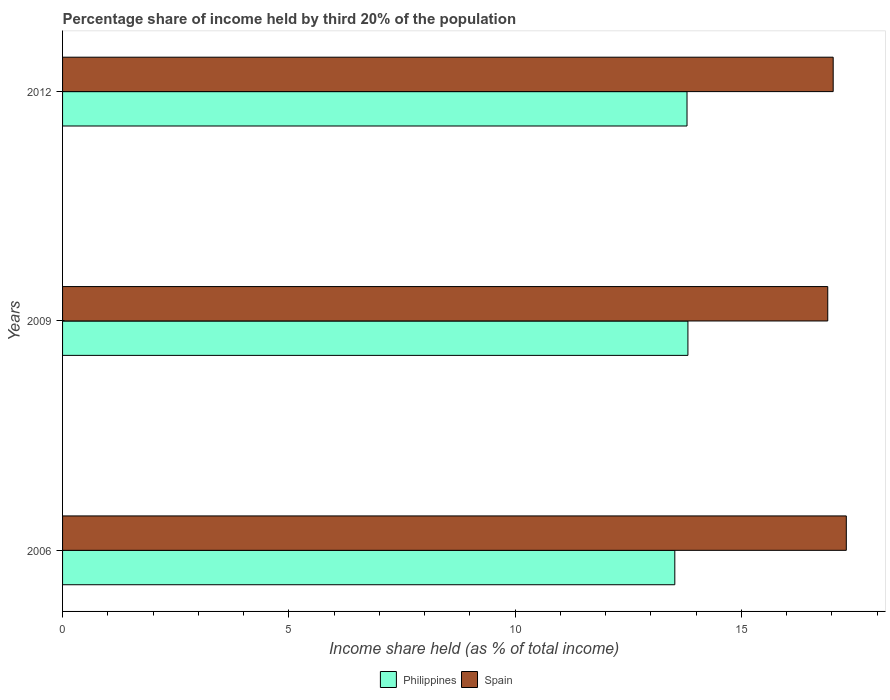How many groups of bars are there?
Give a very brief answer. 3. What is the label of the 3rd group of bars from the top?
Give a very brief answer. 2006. In how many cases, is the number of bars for a given year not equal to the number of legend labels?
Make the answer very short. 0. What is the share of income held by third 20% of the population in Spain in 2006?
Offer a very short reply. 17.32. Across all years, what is the maximum share of income held by third 20% of the population in Spain?
Ensure brevity in your answer.  17.32. Across all years, what is the minimum share of income held by third 20% of the population in Philippines?
Give a very brief answer. 13.53. What is the total share of income held by third 20% of the population in Spain in the graph?
Ensure brevity in your answer.  51.26. What is the difference between the share of income held by third 20% of the population in Spain in 2006 and that in 2009?
Provide a succinct answer. 0.41. What is the difference between the share of income held by third 20% of the population in Spain in 2006 and the share of income held by third 20% of the population in Philippines in 2012?
Ensure brevity in your answer.  3.52. What is the average share of income held by third 20% of the population in Spain per year?
Ensure brevity in your answer.  17.09. In the year 2012, what is the difference between the share of income held by third 20% of the population in Philippines and share of income held by third 20% of the population in Spain?
Keep it short and to the point. -3.23. In how many years, is the share of income held by third 20% of the population in Philippines greater than 7 %?
Your response must be concise. 3. What is the ratio of the share of income held by third 20% of the population in Spain in 2006 to that in 2009?
Your response must be concise. 1.02. Is the share of income held by third 20% of the population in Spain in 2009 less than that in 2012?
Provide a succinct answer. Yes. Is the difference between the share of income held by third 20% of the population in Philippines in 2006 and 2009 greater than the difference between the share of income held by third 20% of the population in Spain in 2006 and 2009?
Provide a short and direct response. No. What is the difference between the highest and the second highest share of income held by third 20% of the population in Philippines?
Provide a short and direct response. 0.02. What is the difference between the highest and the lowest share of income held by third 20% of the population in Philippines?
Offer a very short reply. 0.29. In how many years, is the share of income held by third 20% of the population in Philippines greater than the average share of income held by third 20% of the population in Philippines taken over all years?
Provide a short and direct response. 2. Is the sum of the share of income held by third 20% of the population in Spain in 2009 and 2012 greater than the maximum share of income held by third 20% of the population in Philippines across all years?
Your answer should be very brief. Yes. What does the 2nd bar from the bottom in 2006 represents?
Give a very brief answer. Spain. How many bars are there?
Provide a short and direct response. 6. What is the difference between two consecutive major ticks on the X-axis?
Offer a terse response. 5. Does the graph contain any zero values?
Offer a terse response. No. Does the graph contain grids?
Offer a terse response. No. Where does the legend appear in the graph?
Give a very brief answer. Bottom center. What is the title of the graph?
Make the answer very short. Percentage share of income held by third 20% of the population. What is the label or title of the X-axis?
Your answer should be very brief. Income share held (as % of total income). What is the label or title of the Y-axis?
Make the answer very short. Years. What is the Income share held (as % of total income) of Philippines in 2006?
Give a very brief answer. 13.53. What is the Income share held (as % of total income) of Spain in 2006?
Ensure brevity in your answer.  17.32. What is the Income share held (as % of total income) of Philippines in 2009?
Offer a very short reply. 13.82. What is the Income share held (as % of total income) of Spain in 2009?
Your answer should be compact. 16.91. What is the Income share held (as % of total income) in Spain in 2012?
Provide a short and direct response. 17.03. Across all years, what is the maximum Income share held (as % of total income) of Philippines?
Offer a very short reply. 13.82. Across all years, what is the maximum Income share held (as % of total income) of Spain?
Provide a short and direct response. 17.32. Across all years, what is the minimum Income share held (as % of total income) of Philippines?
Provide a short and direct response. 13.53. Across all years, what is the minimum Income share held (as % of total income) of Spain?
Make the answer very short. 16.91. What is the total Income share held (as % of total income) of Philippines in the graph?
Ensure brevity in your answer.  41.15. What is the total Income share held (as % of total income) of Spain in the graph?
Provide a succinct answer. 51.26. What is the difference between the Income share held (as % of total income) of Philippines in 2006 and that in 2009?
Provide a succinct answer. -0.29. What is the difference between the Income share held (as % of total income) in Spain in 2006 and that in 2009?
Ensure brevity in your answer.  0.41. What is the difference between the Income share held (as % of total income) of Philippines in 2006 and that in 2012?
Keep it short and to the point. -0.27. What is the difference between the Income share held (as % of total income) in Spain in 2006 and that in 2012?
Make the answer very short. 0.29. What is the difference between the Income share held (as % of total income) of Philippines in 2009 and that in 2012?
Ensure brevity in your answer.  0.02. What is the difference between the Income share held (as % of total income) in Spain in 2009 and that in 2012?
Your response must be concise. -0.12. What is the difference between the Income share held (as % of total income) of Philippines in 2006 and the Income share held (as % of total income) of Spain in 2009?
Offer a terse response. -3.38. What is the difference between the Income share held (as % of total income) of Philippines in 2009 and the Income share held (as % of total income) of Spain in 2012?
Your answer should be compact. -3.21. What is the average Income share held (as % of total income) in Philippines per year?
Offer a terse response. 13.72. What is the average Income share held (as % of total income) in Spain per year?
Offer a very short reply. 17.09. In the year 2006, what is the difference between the Income share held (as % of total income) of Philippines and Income share held (as % of total income) of Spain?
Keep it short and to the point. -3.79. In the year 2009, what is the difference between the Income share held (as % of total income) in Philippines and Income share held (as % of total income) in Spain?
Your answer should be compact. -3.09. In the year 2012, what is the difference between the Income share held (as % of total income) in Philippines and Income share held (as % of total income) in Spain?
Provide a succinct answer. -3.23. What is the ratio of the Income share held (as % of total income) of Spain in 2006 to that in 2009?
Give a very brief answer. 1.02. What is the ratio of the Income share held (as % of total income) in Philippines in 2006 to that in 2012?
Ensure brevity in your answer.  0.98. What is the ratio of the Income share held (as % of total income) in Spain in 2009 to that in 2012?
Your answer should be compact. 0.99. What is the difference between the highest and the second highest Income share held (as % of total income) of Philippines?
Make the answer very short. 0.02. What is the difference between the highest and the second highest Income share held (as % of total income) in Spain?
Your response must be concise. 0.29. What is the difference between the highest and the lowest Income share held (as % of total income) of Philippines?
Provide a short and direct response. 0.29. What is the difference between the highest and the lowest Income share held (as % of total income) in Spain?
Your answer should be compact. 0.41. 